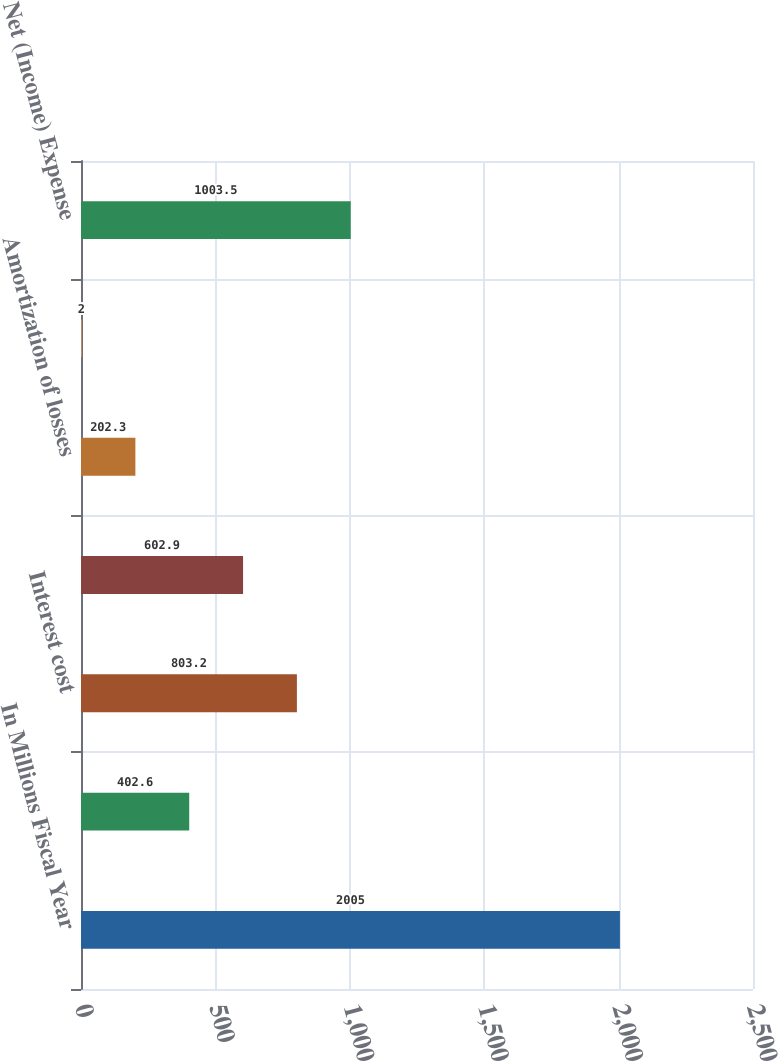<chart> <loc_0><loc_0><loc_500><loc_500><bar_chart><fcel>In Millions Fiscal Year<fcel>Service cost<fcel>Interest cost<fcel>Expected return on plan assets<fcel>Amortization of losses<fcel>Amortization of prior service<fcel>Net (Income) Expense<nl><fcel>2005<fcel>402.6<fcel>803.2<fcel>602.9<fcel>202.3<fcel>2<fcel>1003.5<nl></chart> 